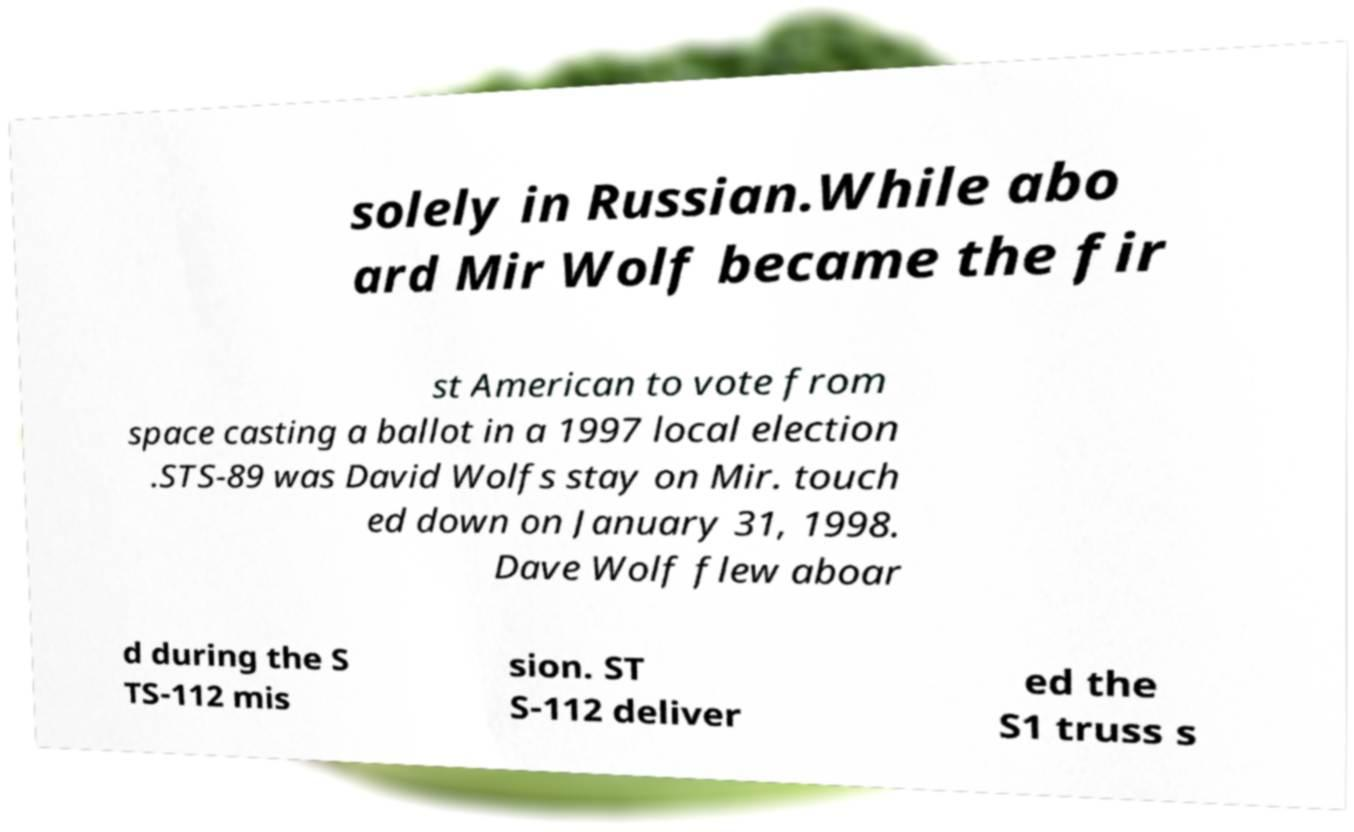What messages or text are displayed in this image? I need them in a readable, typed format. solely in Russian.While abo ard Mir Wolf became the fir st American to vote from space casting a ballot in a 1997 local election .STS-89 was David Wolfs stay on Mir. touch ed down on January 31, 1998. Dave Wolf flew aboar d during the S TS-112 mis sion. ST S-112 deliver ed the S1 truss s 